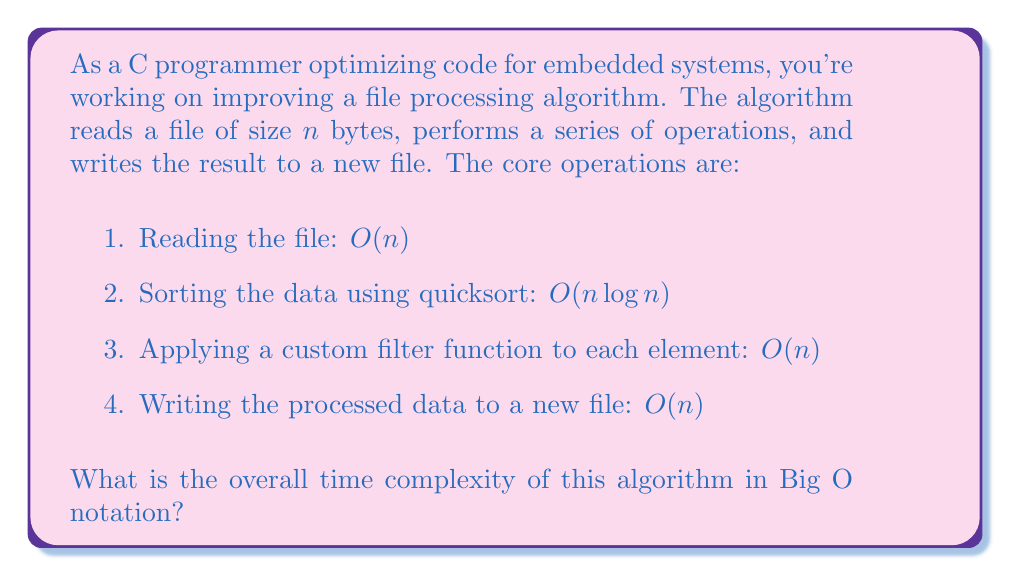Show me your answer to this math problem. To determine the overall time complexity, we need to analyze each step of the algorithm and combine them appropriately:

1. Reading the file: $O(n)$
   This operation is linear in the size of the file.

2. Sorting the data using quicksort: $O(n \log n)$
   Quicksort has an average-case time complexity of $O(n \log n)$.

3. Applying a custom filter function to each element: $O(n)$
   This operation is linear as it processes each element once.

4. Writing the processed data to a new file: $O(n)$
   This operation is also linear in the size of the data.

To combine these complexities, we add them together:

$$O(n) + O(n \log n) + O(n) + O(n)$$

Simplifying this expression:

$$O(n + n \log n + n + n)$$
$$O(3n + n \log n)$$

In Big O notation, we only keep the highest order term and drop constants. The highest order term here is $n \log n$, so we can simplify further:

$$O(n \log n)$$

This is because $n \log n$ grows faster than $n$ for large values of $n$, and constants (like 3) are not significant in Big O notation.
Answer: $O(n \log n)$ 